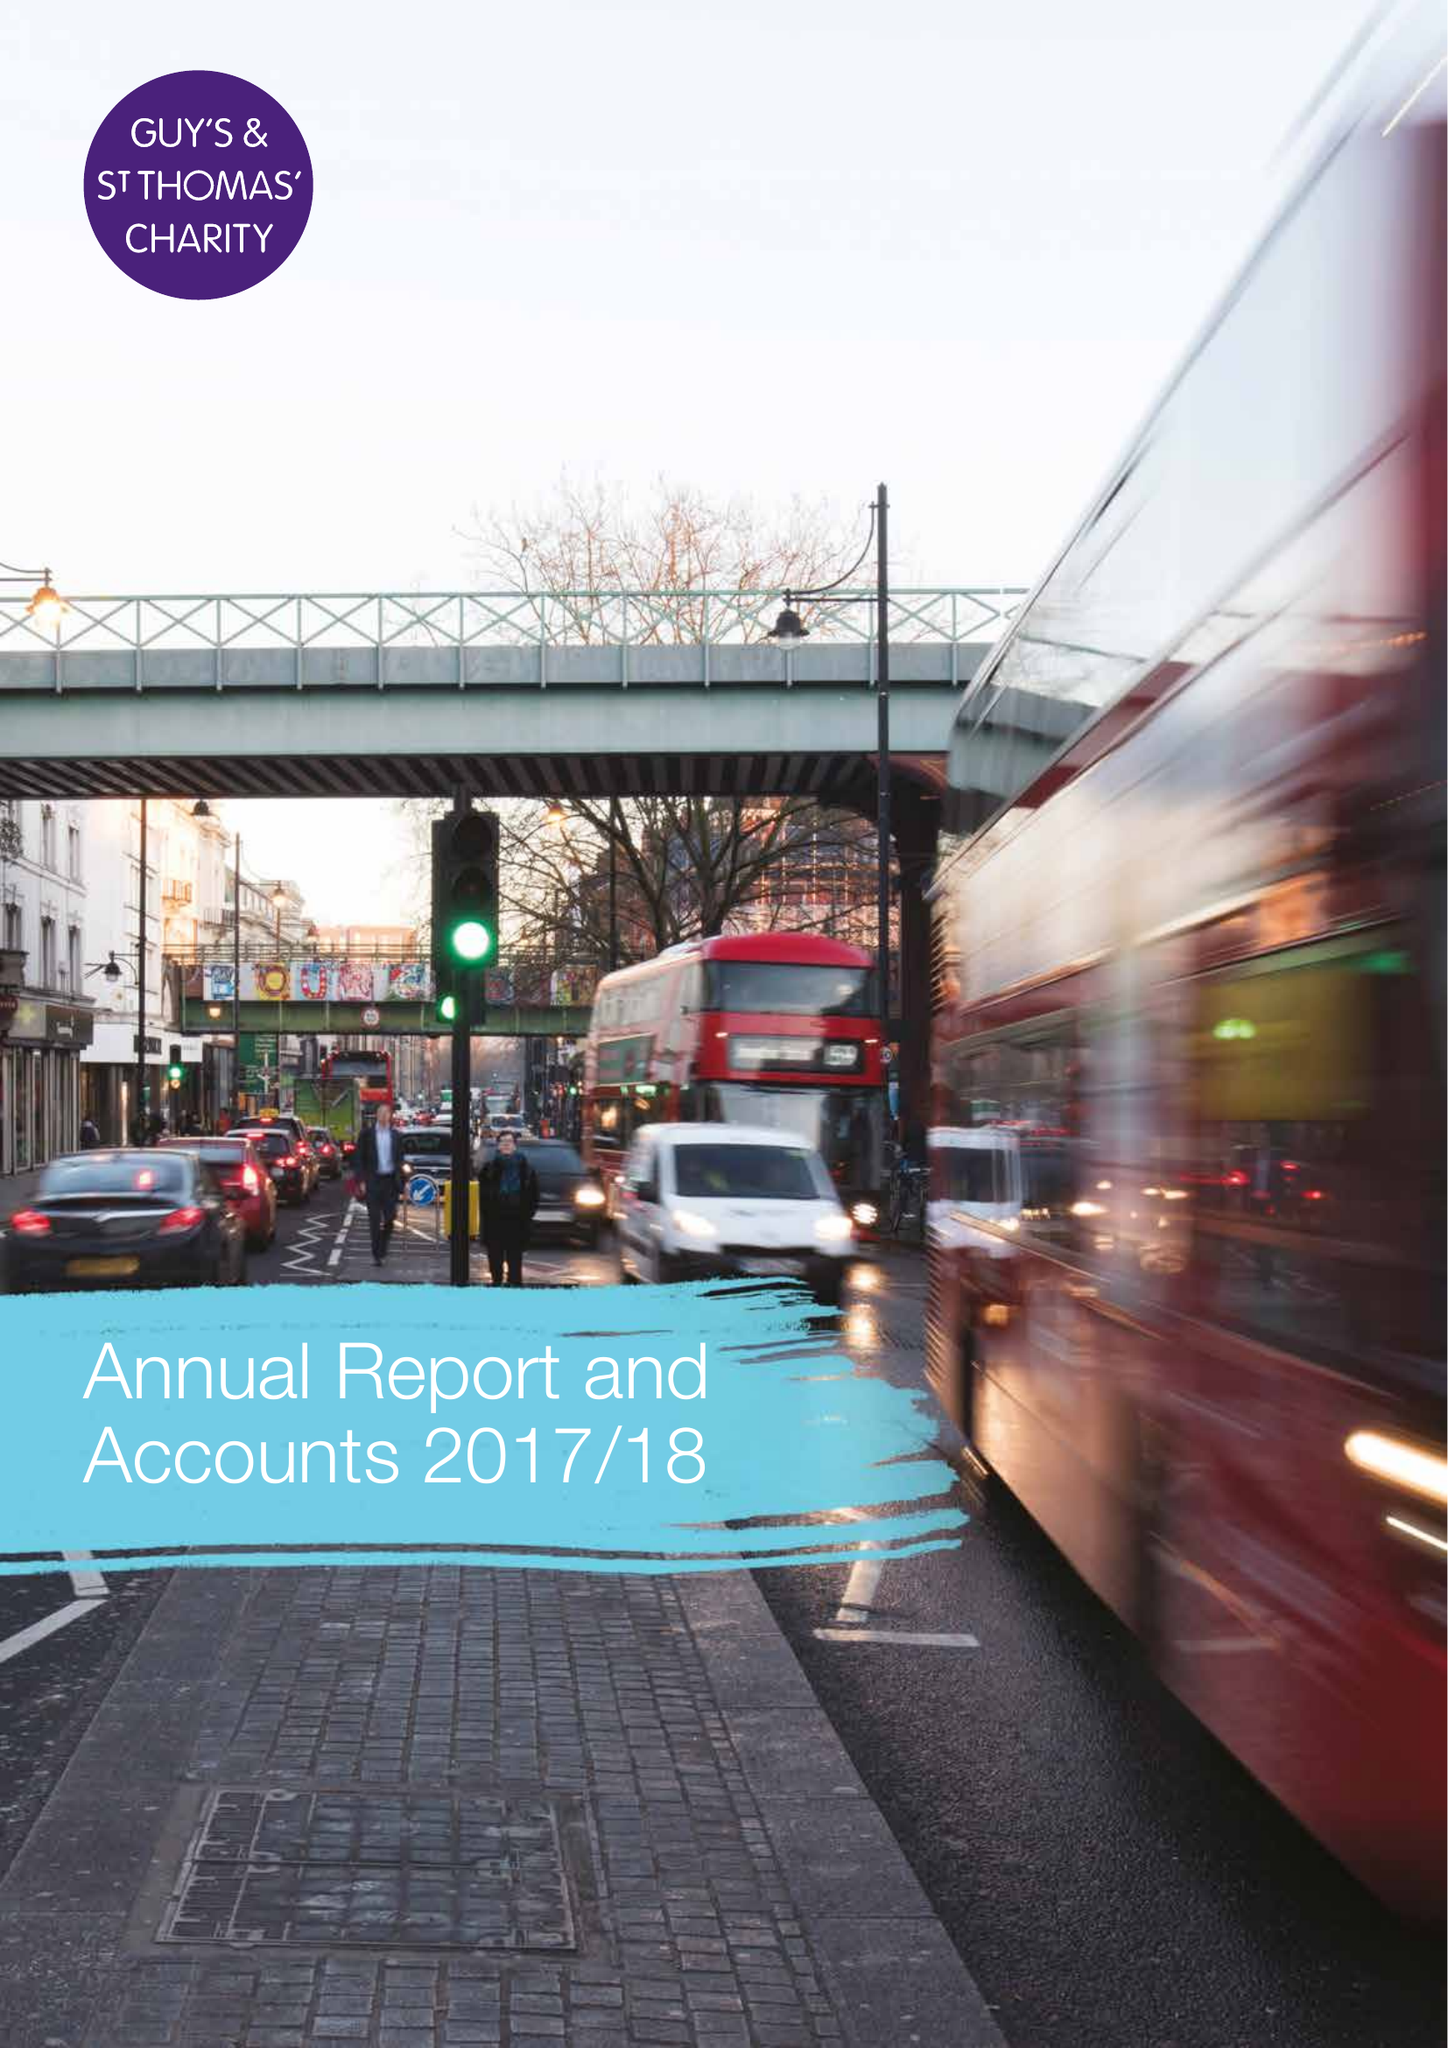What is the value for the address__postcode?
Answer the question using a single word or phrase. SE1 1NA 